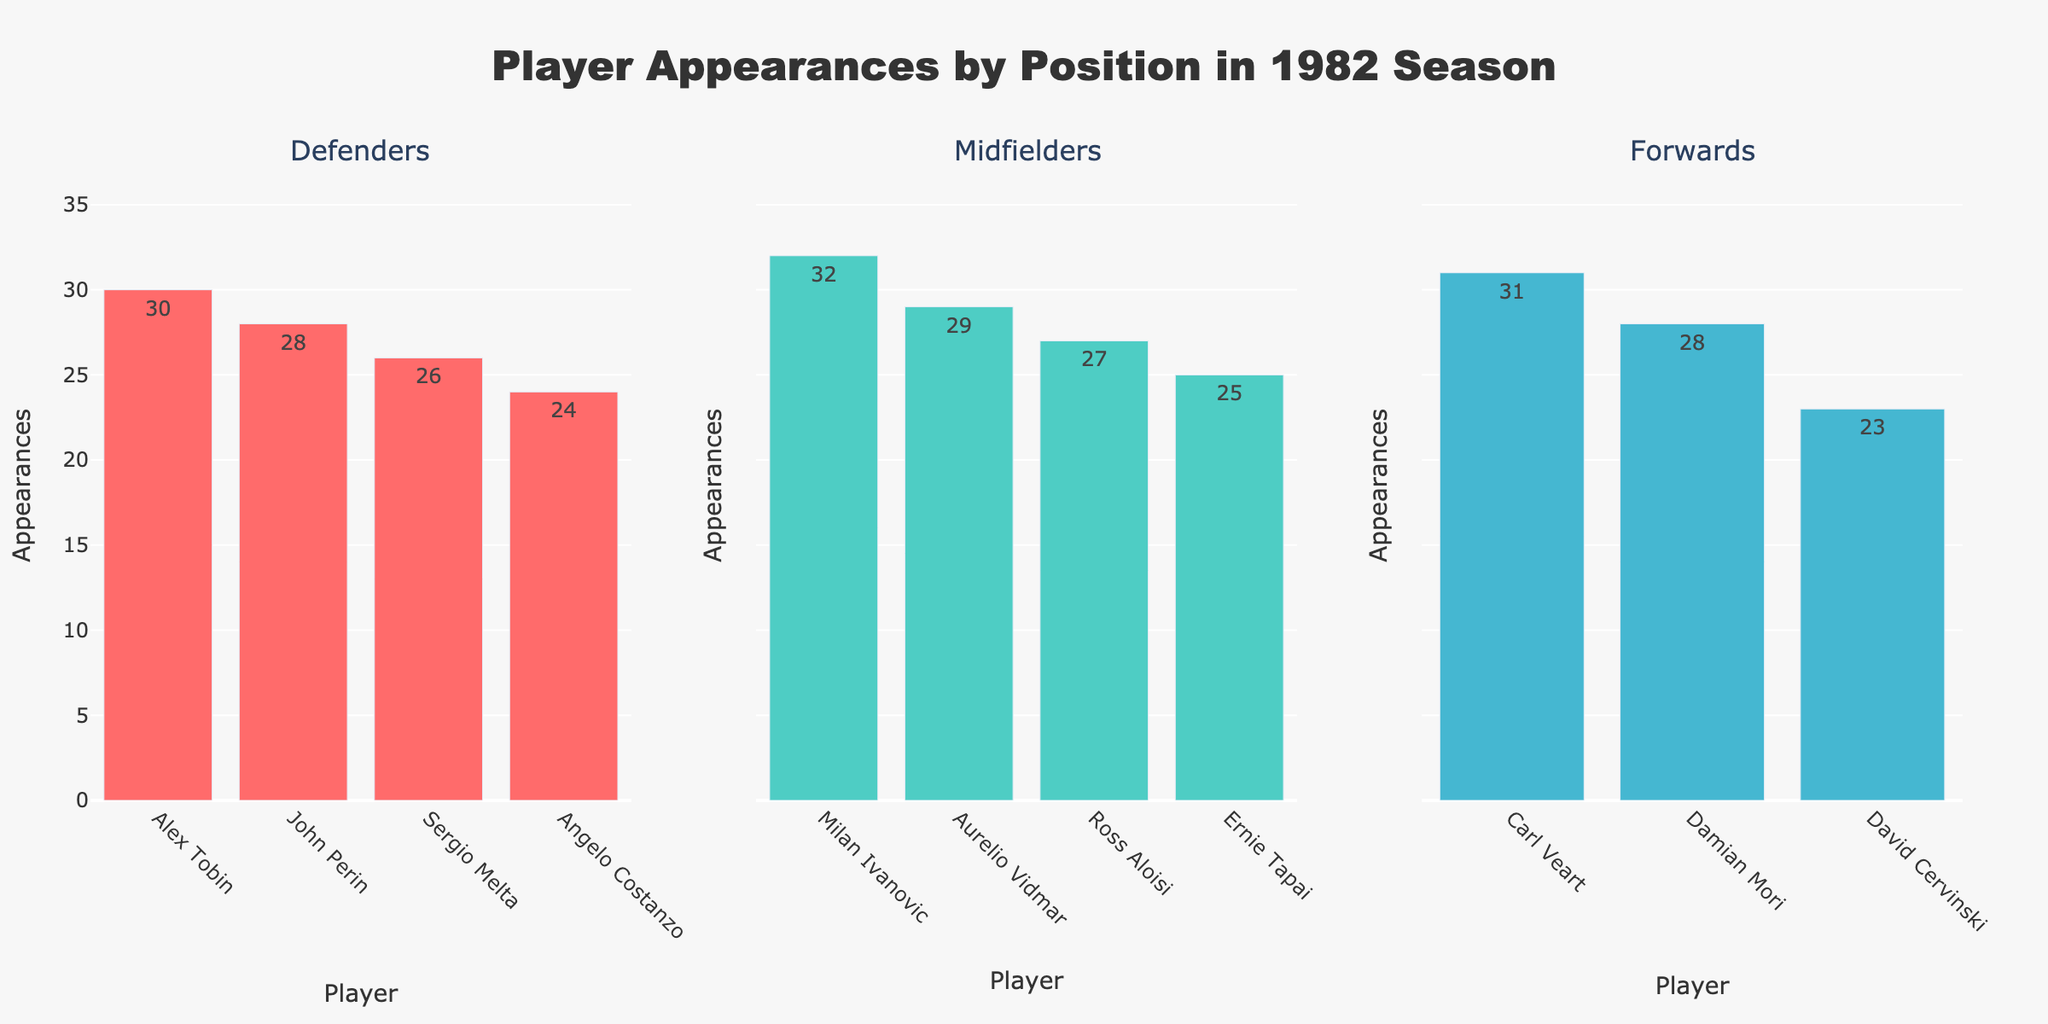What is the title of the figure? The title of the figure is displayed at the top. It reads "Women Representation in STEM Fields Across Countries".
Answer: Women Representation in STEM Fields Across Countries Which country has the highest percentage of women in Computer Science? By looking at the Computer Science subplot, India's bar is the tallest, indicating the highest percentage.
Answer: India In which field do women have the highest representation in the United Kingdom? In the United Kingdom, the Mathematics subplot shows the highest percentage bar among all fields.
Answer: Mathematics What's the difference in the percentage of women in Engineering between Sweden and Japan? The percentage of women in Engineering for Sweden is 29.3, and for Japan, it is 15.3. The difference is 29.3 - 15.3.
Answer: 14.0 What is the range of the y-axis in each subplot? The range of the y-axis, denoted by the percentage values on the left side of each subplot, spans from 0 to 55%.
Answer: 0 to 55% Which country shows the lowest percentage of women in Physics? By examining the Physics subplot, Japan registers the lowest percentage for this field, which is indicated by the shortest bar.
Answer: Japan What is the average percentage of women in Mathematics across all countries? Add the percentages of women in Mathematics from each country and divide by the number of countries: (42.3 + 25.6 + 38.2 + 40.1 + 45.7 + 47.5 + 41.8 + 39.5 + 43.2 + 36.9) / 10.
Answer: 40.08 Compare the representation of women in Physics between Brazil and Australia. The percentage for Brazil is 29.8, and for Australia, it is 24.2. Brazil has a higher representation of women in Physics.
Answer: Brazil What color represents the field of Physics in the subplots? The color used for the Physics subplot is a light orange shade, identified by examining the color palette in the given data.
Answer: Light orange 